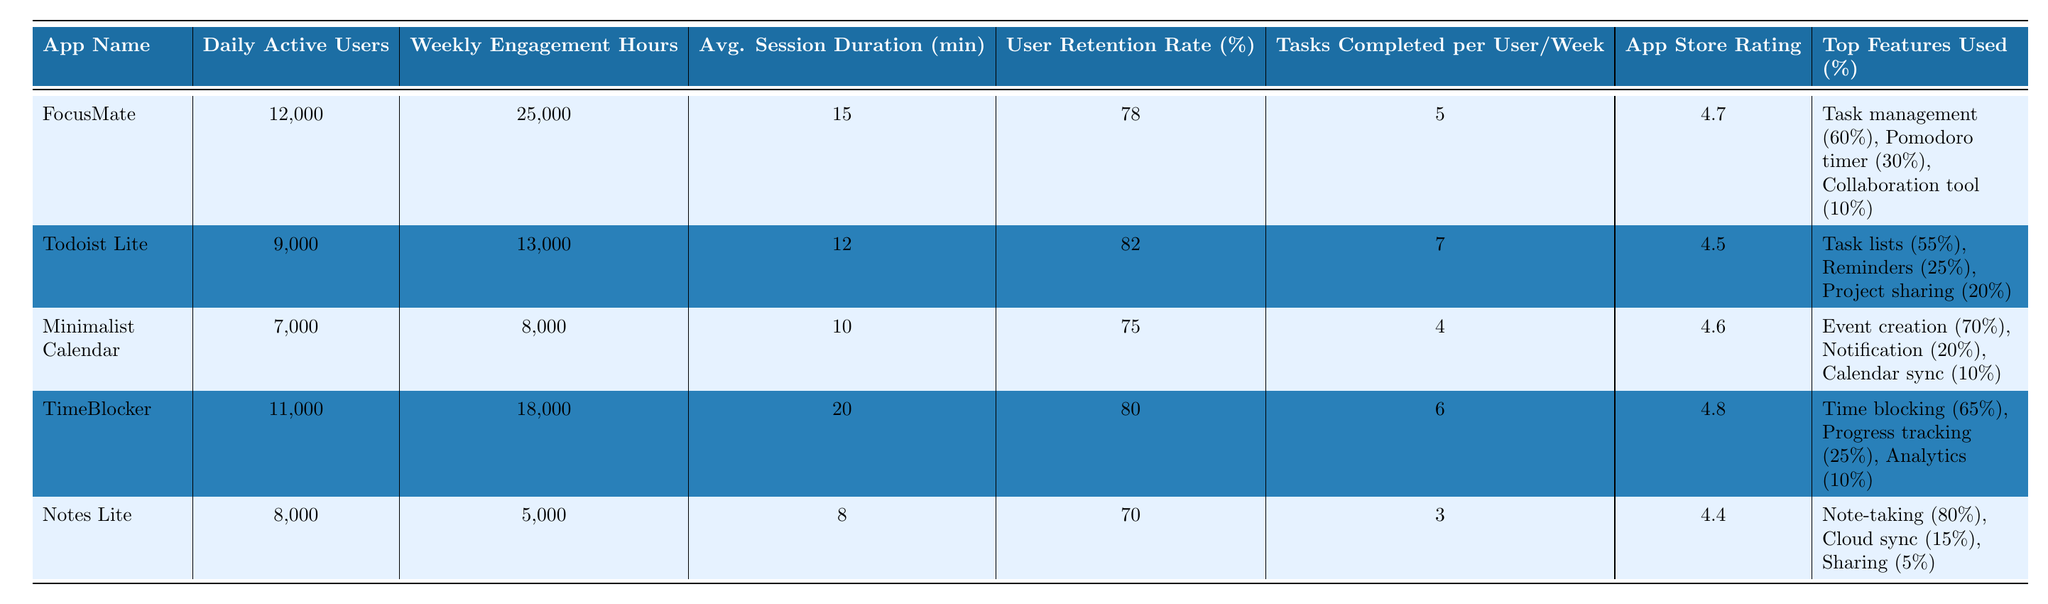What is the app with the highest daily active users? The data shows the daily active users for each app: FocusMate has 12,000, Todoist Lite has 9,000, Minimalist Calendar has 7,000, TimeBlocker has 11,000, and Notes Lite has 8,000. Therefore, FocusMate has the highest daily active users.
Answer: FocusMate Which app has the lowest average session duration? The average session durations for the apps are as follows: FocusMate (15 min), Todoist Lite (12 min), Minimalist Calendar (10 min), TimeBlocker (20 min), and Notes Lite (8 min). Comparing these values, Notes Lite has the lowest average session duration.
Answer: Notes Lite What is the user retention rate for TimeBlocker? The user retention rates listed in the table show that TimeBlocker has a user retention rate of 80%.
Answer: 80% What is the average number of tasks completed per user per week for all apps? The tasks completed per user per week are: FocusMate (5), Todoist Lite (7), Minimalist Calendar (4), TimeBlocker (6), and Notes Lite (3). The sum is 5 + 7 + 4 + 6 + 3 = 25. There are 5 apps, so the average is 25/5 = 5.
Answer: 5 Which app has the highest app store rating? The app store ratings listed are FocusMate (4.7), Todoist Lite (4.5), Minimalist Calendar (4.6), TimeBlocker (4.8), and Notes Lite (4.4). Comparing these ratings, TimeBlocker has the highest rating at 4.8.
Answer: TimeBlocker Is the user retention rate for Minimalist Calendar greater than or equal to 75%? The user retention rate for Minimalist Calendar is given as 75%. Since it is equal to 75%, the statement is true.
Answer: Yes Which app has the highest engagement hours and what is that number? The weekly engagement hours for each app are: FocusMate (25,000), Todoist Lite (13,000), Minimalist Calendar (8,000), TimeBlocker (18,000), and Notes Lite (5,000). FocusMate has the highest engagement hours at 25,000.
Answer: 25,000 What percentage of users utilize the collaboration tool feature in FocusMate? The features used percentage for FocusMate shows that 10% of users utilize the collaboration tool.
Answer: 10% Which app shows the lowest user retention rate and what is it? The user retention rates for the apps are: FocusMate (78%), Todoist Lite (82%), Minimalist Calendar (75%), TimeBlocker (80%), and Notes Lite (70%). Thus, Notes Lite has the lowest retention rate of 70%.
Answer: 70% If you combine the daily active users for Todoist Lite and Minimalist Calendar, what is the total? The daily active users are: Todoist Lite (9,000) and Minimalist Calendar (7,000). Adding them gives 9,000 + 7,000 = 16,000.
Answer: 16,000 